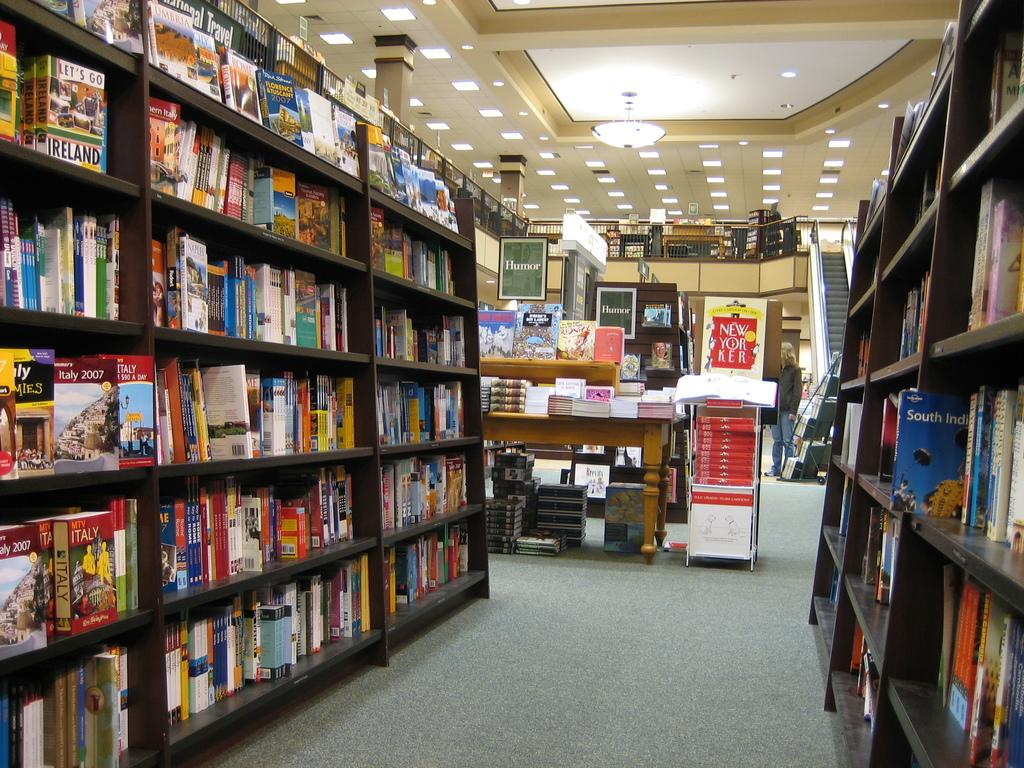<image>
Provide a brief description of the given image. The travel section of a book store includes several on the destination of Italy. 